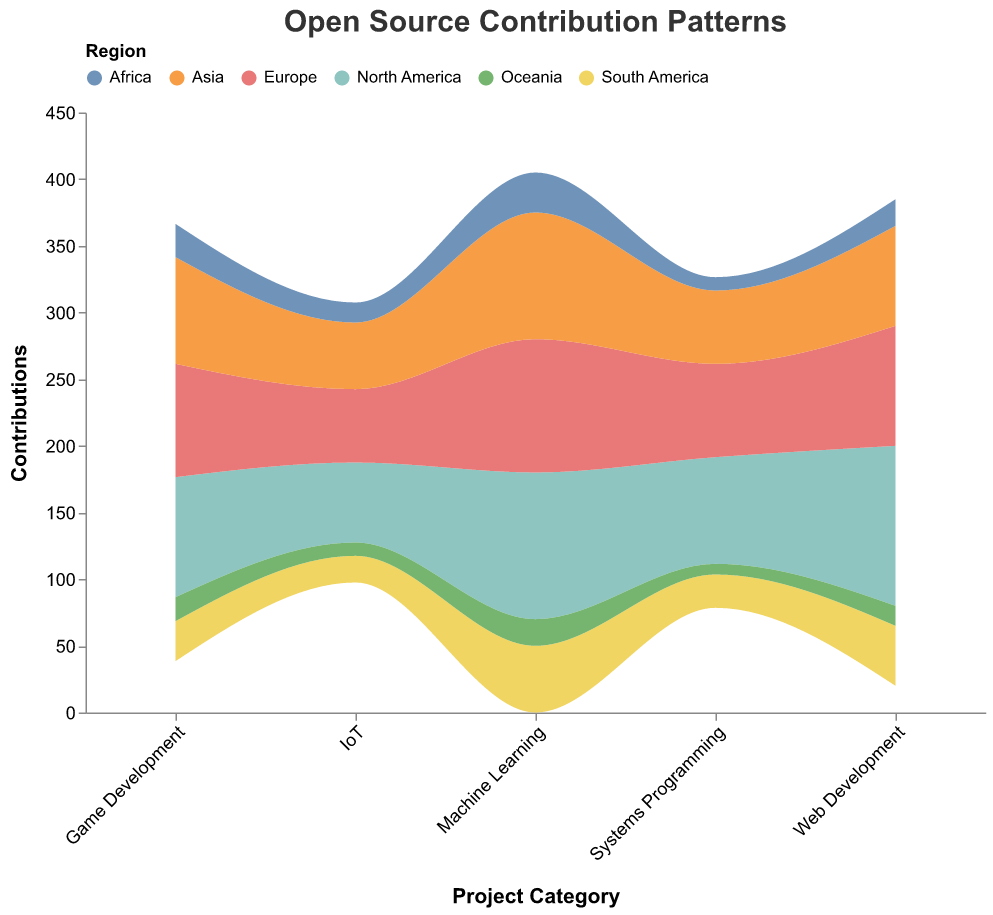What is the project category with the highest total contributions from North America in 2021? By visually examining the height of the areas corresponding to North America within each project category, we see that "Web Development" has the tallest area for North America, which is 120 contributions. The next highest is "Machine Learning" with 110 contributions.
Answer: Web Development Which region has the fewest contributions to "Systems Programming" projects in 2021? By examining the color-coded regions stacked in the "Systems Programming" category, the smallest area corresponds to Oceania, indicating it has the fewest contributions, which is 8.
Answer: Oceania How many more contributions does "Machine Learning" have from Europe compared to "IoT" from Europe in 2021? Contributions from Europe to "Machine Learning" projects are 100, and to "IoT" projects are 55. The difference is 100 - 55 = 45 contributions.
Answer: 45 What is the total number of contributions to "Game Development" projects across all regions in 2021? By summing up the contributions for each region in the "Game Development" category, we get: 90 (North America) + 85 (Europe) + 80 (Asia) + 30 (South America) + 25 (Africa) + 18 (Oceania) = 328.
Answer: 328 Which project category receives the most balanced contribution across all regions? Examining the visual distribution, "IoT" projects show the smallest variance in height across regions, indicating a more balanced contribution pattern with numbers ranging from 10 to 60 contributions across different regions.
Answer: IoT Compare the contributions from Asia to "Machine Learning" and "Web Development" Contributions from Asia for "Machine Learning" are 95, and for "Web Development," they are 75. Machine Learning has more contributions.
Answer: Machine Learning What is the total number of contributions made to projects from Africa in 2021? Adding up all contributions from Africa across the project categories, we get: 20 (Web Development) + 10 (Systems Programming) + 30 (Machine Learning) + 15 (IoT) + 25 (Game Development) = 100.
Answer: 100 What region contributes the most to "Web Development" projects? By examining the color-coded regions in "Web Development," North America has the highest area, indicating the most contributions at 120.
Answer: North America 